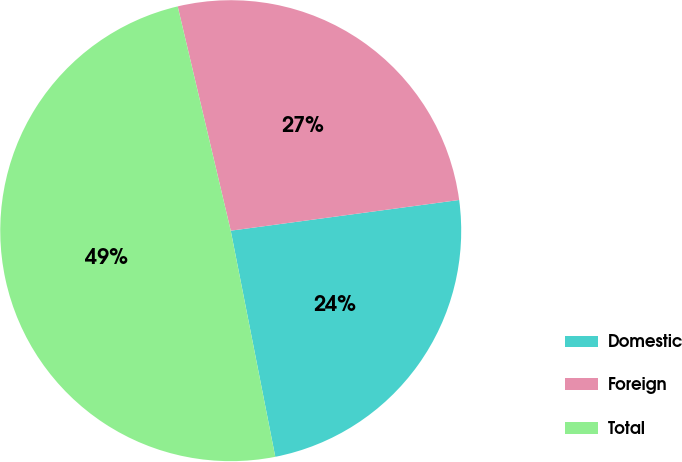Convert chart. <chart><loc_0><loc_0><loc_500><loc_500><pie_chart><fcel>Domestic<fcel>Foreign<fcel>Total<nl><fcel>24.03%<fcel>26.57%<fcel>49.4%<nl></chart> 